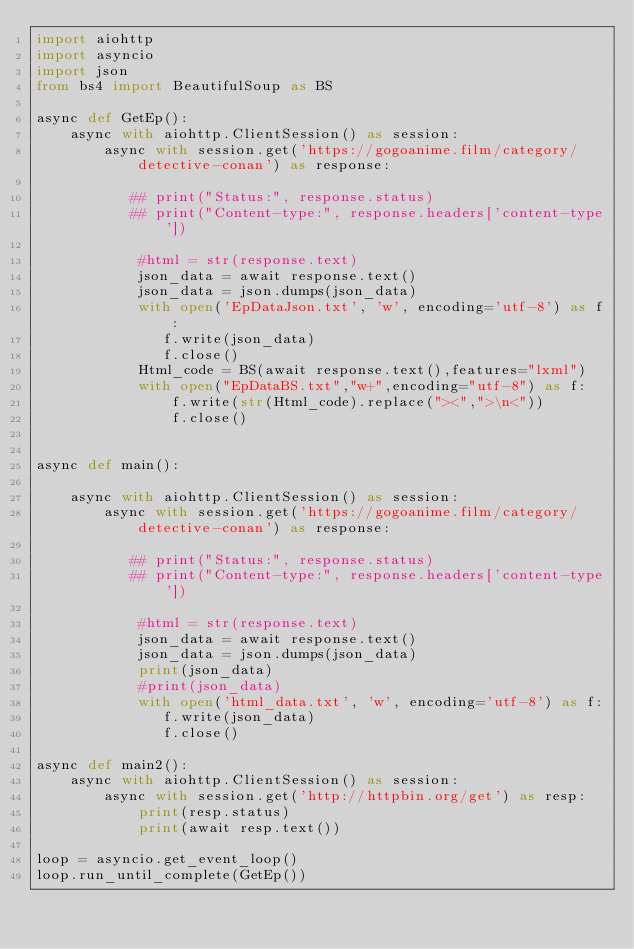Convert code to text. <code><loc_0><loc_0><loc_500><loc_500><_Python_>import aiohttp
import asyncio
import json
from bs4 import BeautifulSoup as BS

async def GetEp():
    async with aiohttp.ClientSession() as session:
        async with session.get('https://gogoanime.film/category/detective-conan') as response:

           ## print("Status:", response.status)
           ## print("Content-type:", response.headers['content-type'])

            #html = str(response.text)
            json_data = await response.text()
            json_data = json.dumps(json_data)
            with open('EpDataJson.txt', 'w', encoding='utf-8') as f:
               f.write(json_data)
               f.close()
            Html_code = BS(await response.text(),features="lxml")
            with open("EpDataBS.txt","w+",encoding="utf-8") as f:
                f.write(str(Html_code).replace("><",">\n<"))
                f.close()


async def main():

    async with aiohttp.ClientSession() as session:
        async with session.get('https://gogoanime.film/category/detective-conan') as response:

           ## print("Status:", response.status)
           ## print("Content-type:", response.headers['content-type'])

            #html = str(response.text)
            json_data = await response.text()
            json_data = json.dumps(json_data)
            print(json_data)
            #print(json_data)
            with open('html_data.txt', 'w', encoding='utf-8') as f:
               f.write(json_data)
               f.close()

async def main2():
    async with aiohttp.ClientSession() as session:
        async with session.get('http://httpbin.org/get') as resp:
            print(resp.status)
            print(await resp.text())

loop = asyncio.get_event_loop()
loop.run_until_complete(GetEp())</code> 